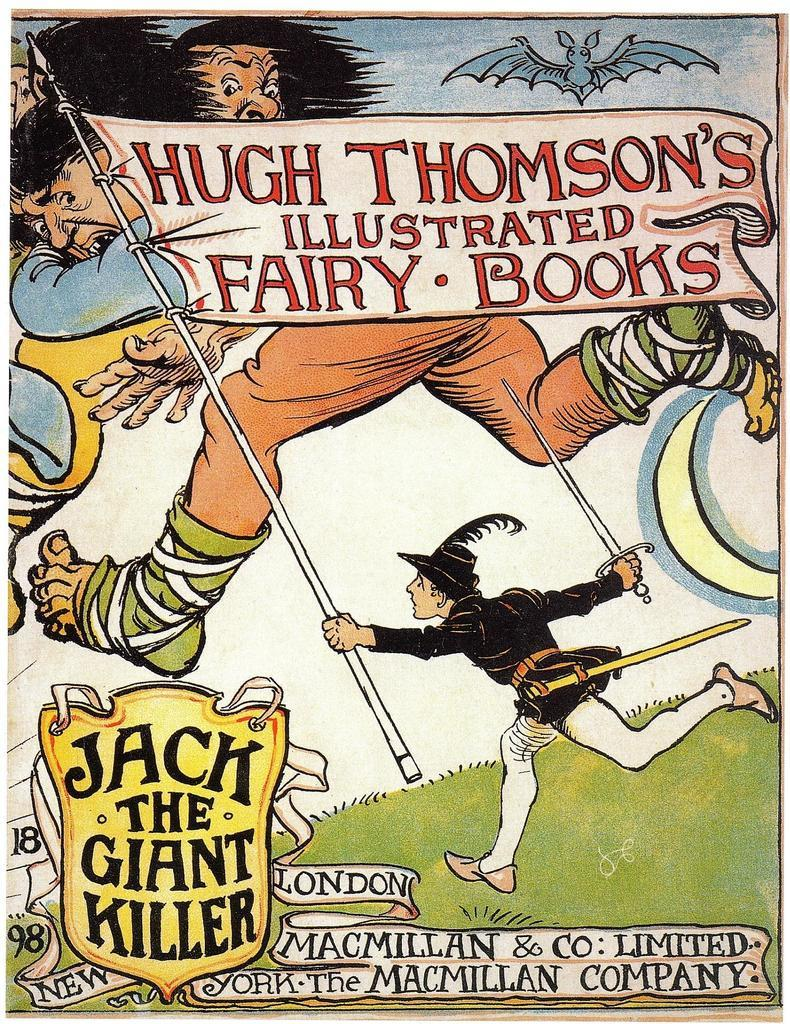Provide a one-sentence caption for the provided image. Poster for Jack The Giant Killer showing a man holding a flag. 